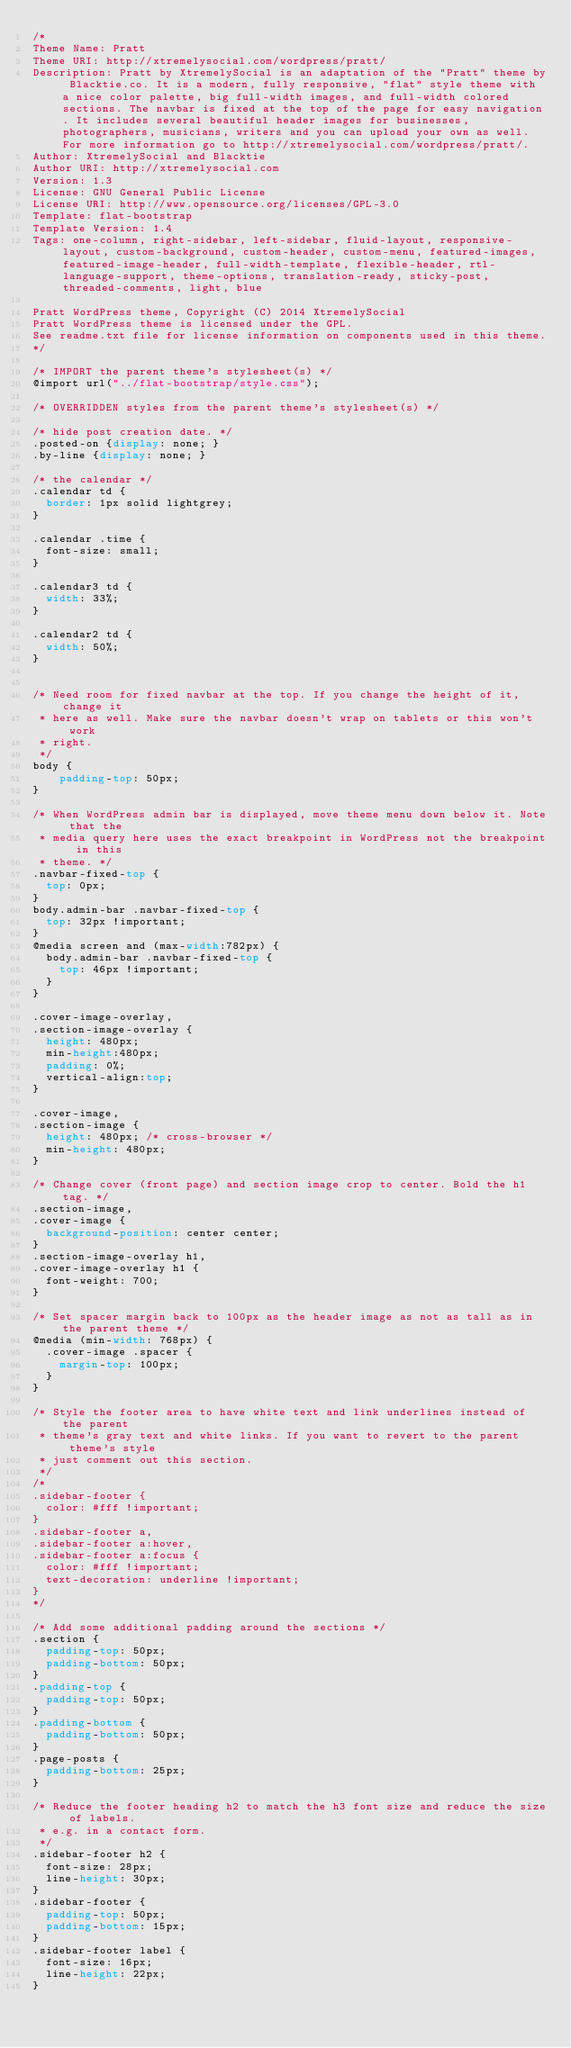Convert code to text. <code><loc_0><loc_0><loc_500><loc_500><_CSS_>/*
Theme Name: Pratt
Theme URI: http://xtremelysocial.com/wordpress/pratt/
Description: Pratt by XtremelySocial is an adaptation of the "Pratt" theme by Blacktie.co. It is a modern, fully responsive, "flat" style theme with a nice color palette, big full-width images, and full-width colored sections. The navbar is fixed at the top of the page for easy navigation. It includes several beautiful header images for businesses, photographers, musicians, writers and you can upload your own as well. For more information go to http://xtremelysocial.com/wordpress/pratt/.
Author: XtremelySocial and Blacktie
Author URI: http://xtremelysocial.com
Version: 1.3
License: GNU General Public License
License URI: http://www.opensource.org/licenses/GPL-3.0
Template: flat-bootstrap
Template Version: 1.4
Tags: one-column, right-sidebar, left-sidebar, fluid-layout, responsive-layout, custom-background, custom-header, custom-menu, featured-images, featured-image-header, full-width-template, flexible-header, rtl-language-support, theme-options, translation-ready, sticky-post, threaded-comments, light, blue

Pratt WordPress theme, Copyright (C) 2014 XtremelySocial
Pratt WordPress theme is licensed under the GPL.
See readme.txt file for license information on components used in this theme.
*/

/* IMPORT the parent theme's stylesheet(s) */
@import url("../flat-bootstrap/style.css");

/* OVERRIDDEN styles from the parent theme's stylesheet(s) */

/* hide post creation date. */
.posted-on {display: none; }
.by-line {display: none; }

/* the calendar */
.calendar td {
	border: 1px solid lightgrey;
}

.calendar .time {
	font-size: small;
}

.calendar3 td {
	width: 33%;
}

.calendar2 td {
	width: 50%;
}


/* Need room for fixed navbar at the top. If you change the height of it, change it 
 * here as well. Make sure the navbar doesn't wrap on tablets or this won't work 
 * right.
 */
body {
    padding-top: 50px;
}

/* When WordPress admin bar is displayed, move theme menu down below it. Note that the
 * media query here uses the exact breakpoint in WordPress not the breakpoint in this
 * theme. */
.navbar-fixed-top { 
	top: 0px; 
}
body.admin-bar .navbar-fixed-top { 
	top: 32px !important; 
}
@media screen and (max-width:782px) {
	body.admin-bar .navbar-fixed-top {
		top: 46px !important; 
	}
}

.cover-image-overlay,
.section-image-overlay {
	height: 480px;
	min-height:480px;
	padding: 0%;
	vertical-align:top;
}

.cover-image, 
.section-image {
	height: 480px; /* cross-browser */
	min-height: 480px;
}

/* Change cover (front page) and section image crop to center. Bold the h1 tag. */
.section-image, 
.cover-image {
	background-position: center center;
}
.section-image-overlay h1, 
.cover-image-overlay h1 {
	font-weight: 700;
}

/* Set spacer margin back to 100px as the header image as not as tall as in the parent theme */
@media (min-width: 768px) {
	.cover-image .spacer {
		margin-top: 100px;
	}
}

/* Style the footer area to have white text and link underlines instead of the parent
 * theme's gray text and white links. If you want to revert to the parent theme's style
 * just comment out this section.
 */
/*
.sidebar-footer {
	color: #fff !important;
}
.sidebar-footer a, 
.sidebar-footer a:hover, 
.sidebar-footer a:focus {
	color: #fff !important;
	text-decoration: underline !important;
}
*/

/* Add some additional padding around the sections */
.section {
	padding-top: 50px;
	padding-bottom: 50px;
}
.padding-top {
	padding-top: 50px;
}
.padding-bottom {
	padding-bottom: 50px;
}
.page-posts {
	padding-bottom: 25px;
}

/* Reduce the footer heading h2 to match the h3 font size and reduce the size of labels. 
 * e.g. in a contact form.
 */
.sidebar-footer h2 {
	font-size: 28px;
	line-height: 30px;
}
.sidebar-footer {
	padding-top: 50px;
	padding-bottom: 15px;
}
.sidebar-footer label {
	font-size: 16px;
	line-height: 22px;
}
</code> 